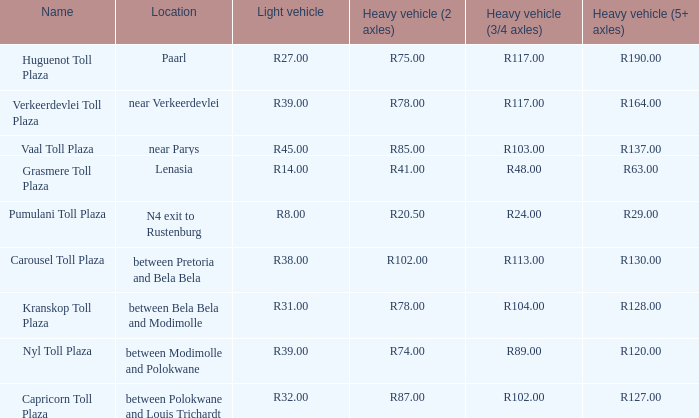What is the name of the plaza where the told for heavy vehicles with 2 axles is r20.50? Pumulani Toll Plaza. 